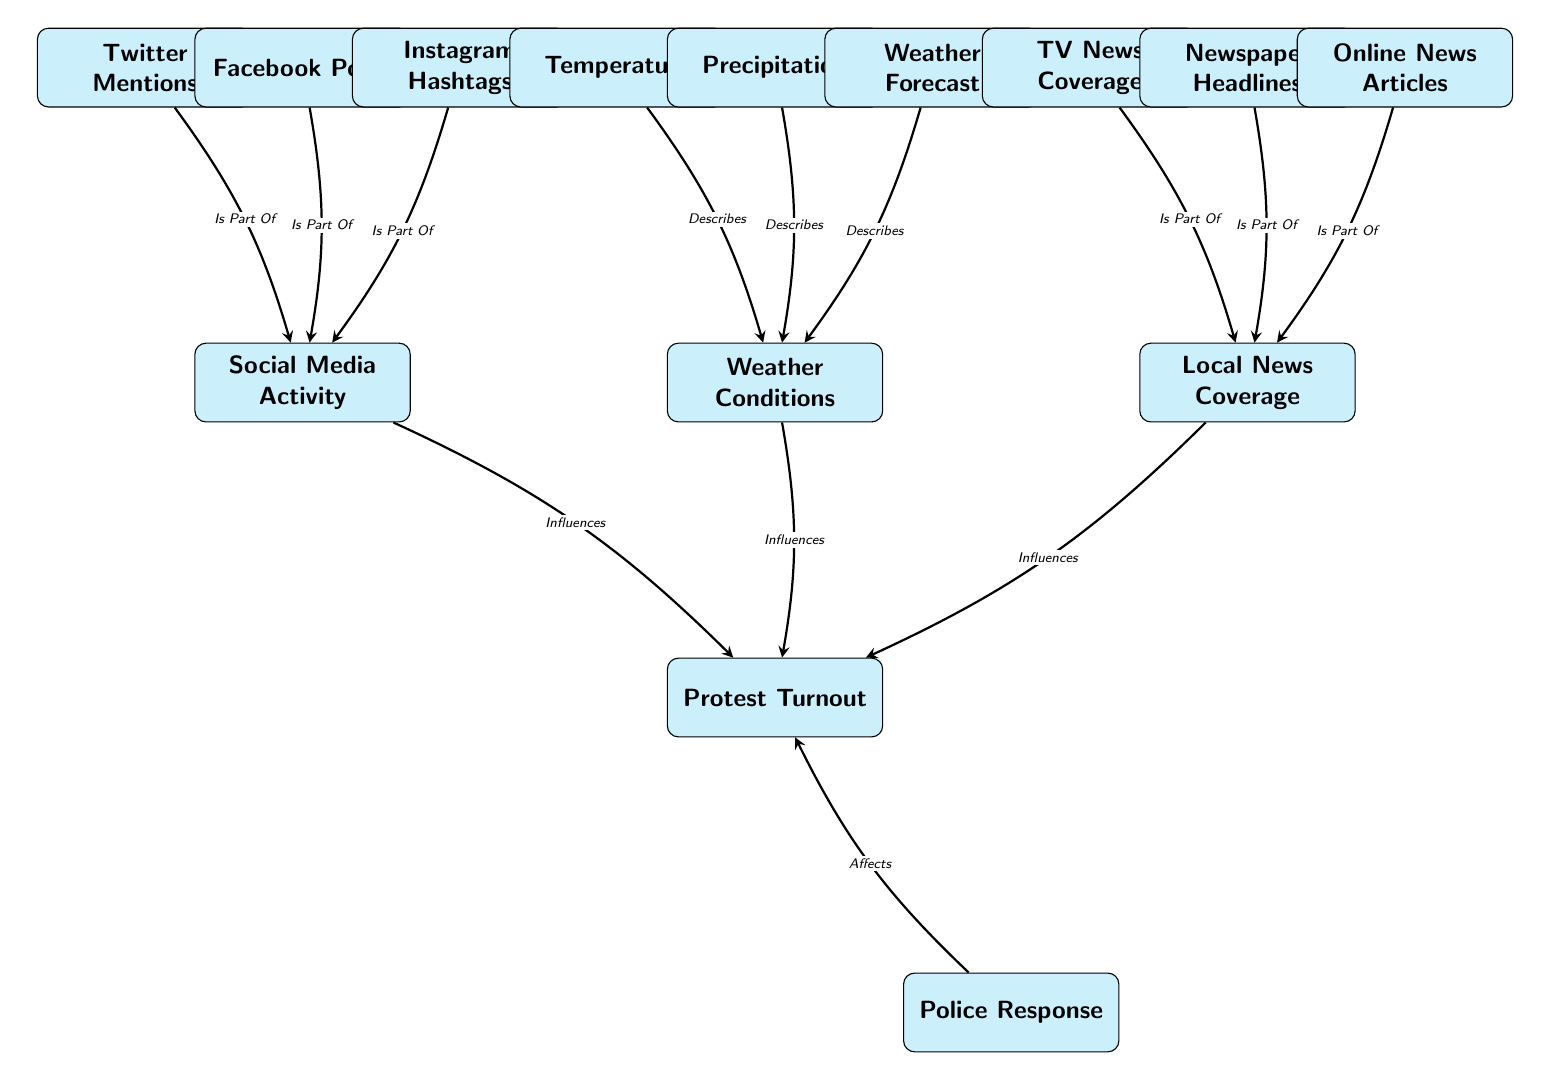What are the three main influences on Protest Turnout? The diagram lists three main influences on Protest Turnout: Social Media Activity, Weather Conditions, and Local News Coverage, which are the nodes directly connected to the Protest Turnout node.
Answer: Social Media Activity, Weather Conditions, Local News Coverage How many nodes describe Weather Conditions? Three nodes describe Weather Conditions: Temperature, Precipitation, and Weather Forecast are directly linked to the Weather Conditions node, indicating they provide descriptive information about it.
Answer: 3 What is the relationship between Local News Coverage and TV News Coverage? The diagram indicates that TV News Coverage is a part of Local News Coverage, shown by the directed edge connecting the two nodes with the label "Is Part Of".
Answer: Is Part Of How does Police Response affect Protest Turnout? Police Response is placed below the Protest Turnout node, directly indicating that it affects the outcome of the Protest Turnout through an edge labeled "Affects."
Answer: Affects How many total edges are there in the diagram? By counting all the connections (edges) that link the nodes in the diagram, a total of eight edges can be identified: three influencing Protest Turnout, three part of Social Media Activity, three part of Local News Coverage, and one for Police Response.
Answer: 8 What are the components of Social Media Activity? The nodes that are part of Social Media Activity include Twitter Mentions, Facebook Posts, and Instagram Hashtags, indicating they collectively influence this broader category.
Answer: Twitter Mentions, Facebook Posts, Instagram Hashtags Which node describes a weather factor related to precipitation? The Precipitation node is connected to Weather Conditions and describes a weather factor directly linked to it. This can be determined from the edge labeled "Describes" indicating this relationship.
Answer: Precipitation What type of diagram is this and what is its focus? This diagram is a Machine Learning Diagram, focusing on Predictive Analysis of Protest Turnout while showing the influences of various factors like social media activity, weather conditions, and local news coverage on it.
Answer: Machine Learning Diagram, Predictive Analysis of Protest Turnout 